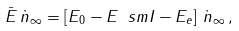<formula> <loc_0><loc_0><loc_500><loc_500>\bar { E } \, \dot { n } _ { \infty } = \left [ E _ { 0 } - E _ { \ } s m I - E _ { e } \right ] \, \dot { n } _ { \infty } \, ,</formula> 